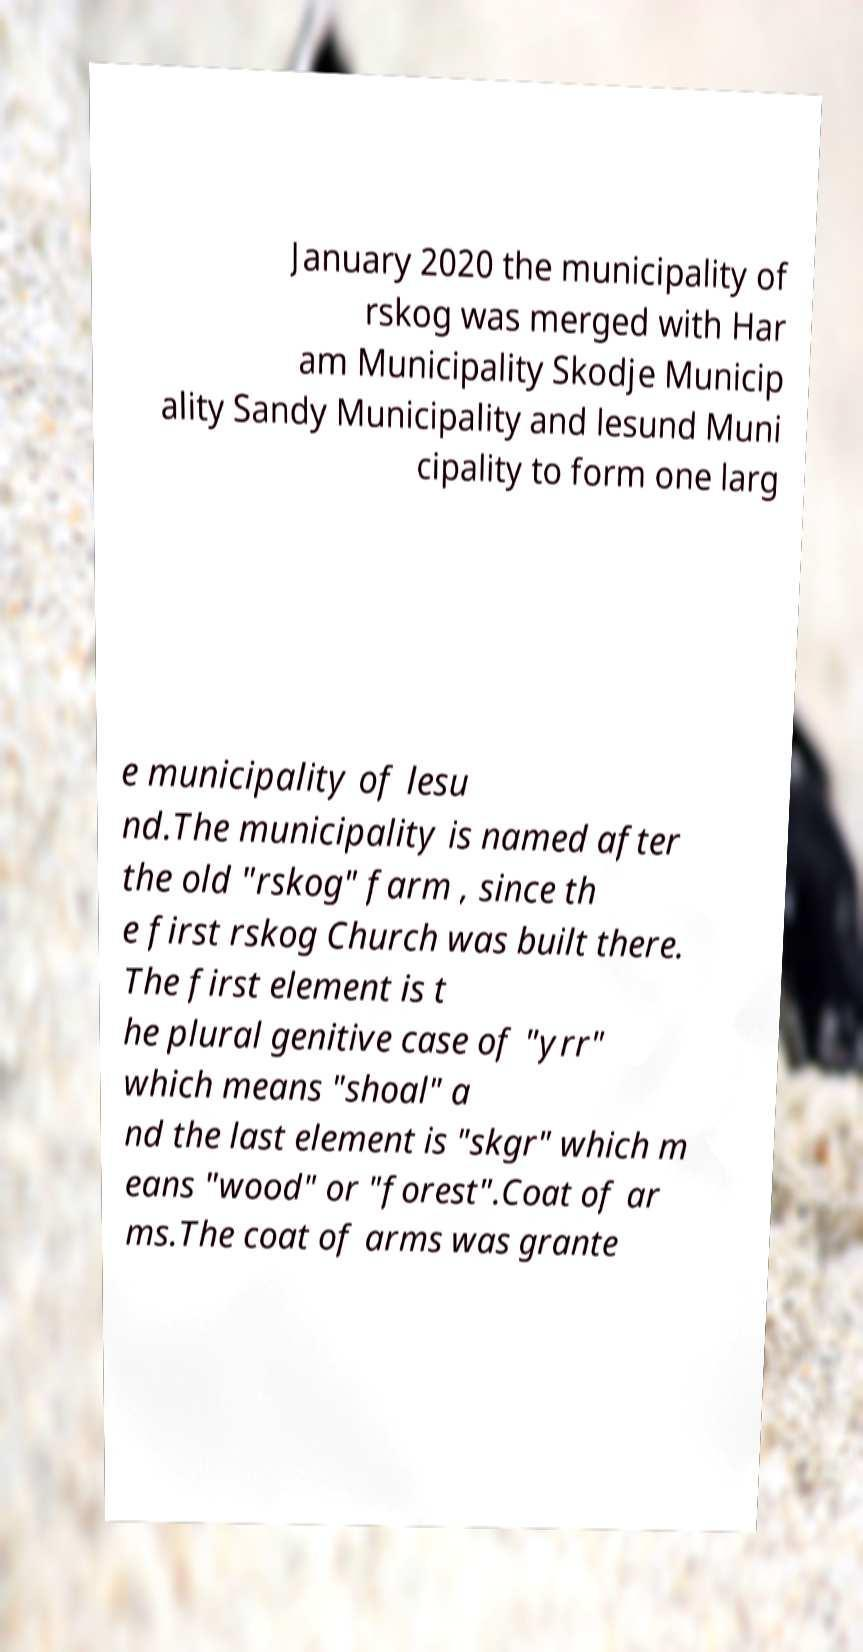Please read and relay the text visible in this image. What does it say? January 2020 the municipality of rskog was merged with Har am Municipality Skodje Municip ality Sandy Municipality and lesund Muni cipality to form one larg e municipality of lesu nd.The municipality is named after the old "rskog" farm , since th e first rskog Church was built there. The first element is t he plural genitive case of "yrr" which means "shoal" a nd the last element is "skgr" which m eans "wood" or "forest".Coat of ar ms.The coat of arms was grante 